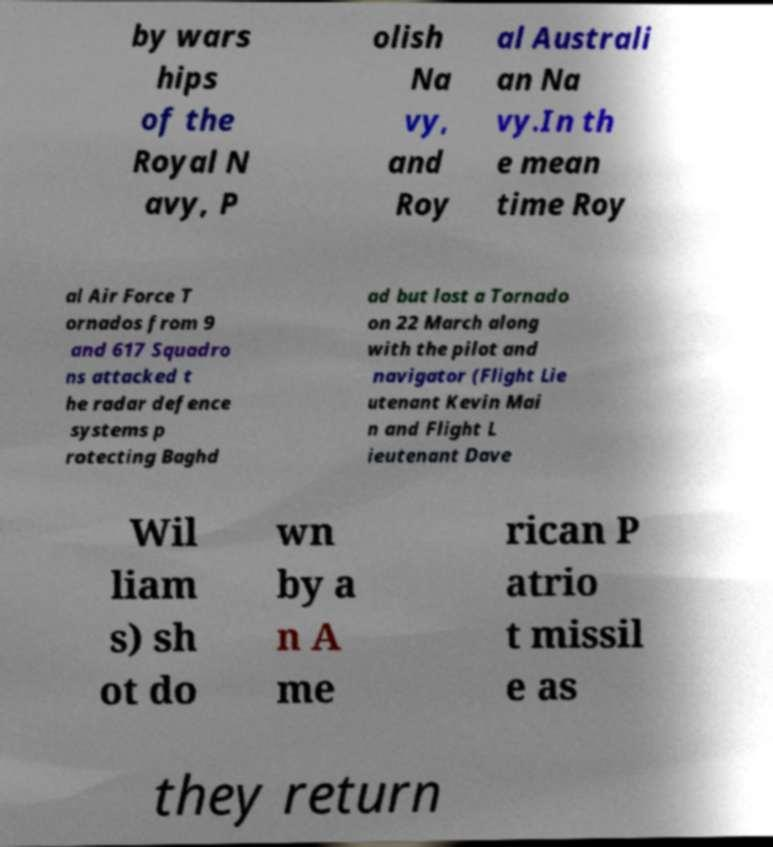Could you assist in decoding the text presented in this image and type it out clearly? by wars hips of the Royal N avy, P olish Na vy, and Roy al Australi an Na vy.In th e mean time Roy al Air Force T ornados from 9 and 617 Squadro ns attacked t he radar defence systems p rotecting Baghd ad but lost a Tornado on 22 March along with the pilot and navigator (Flight Lie utenant Kevin Mai n and Flight L ieutenant Dave Wil liam s) sh ot do wn by a n A me rican P atrio t missil e as they return 